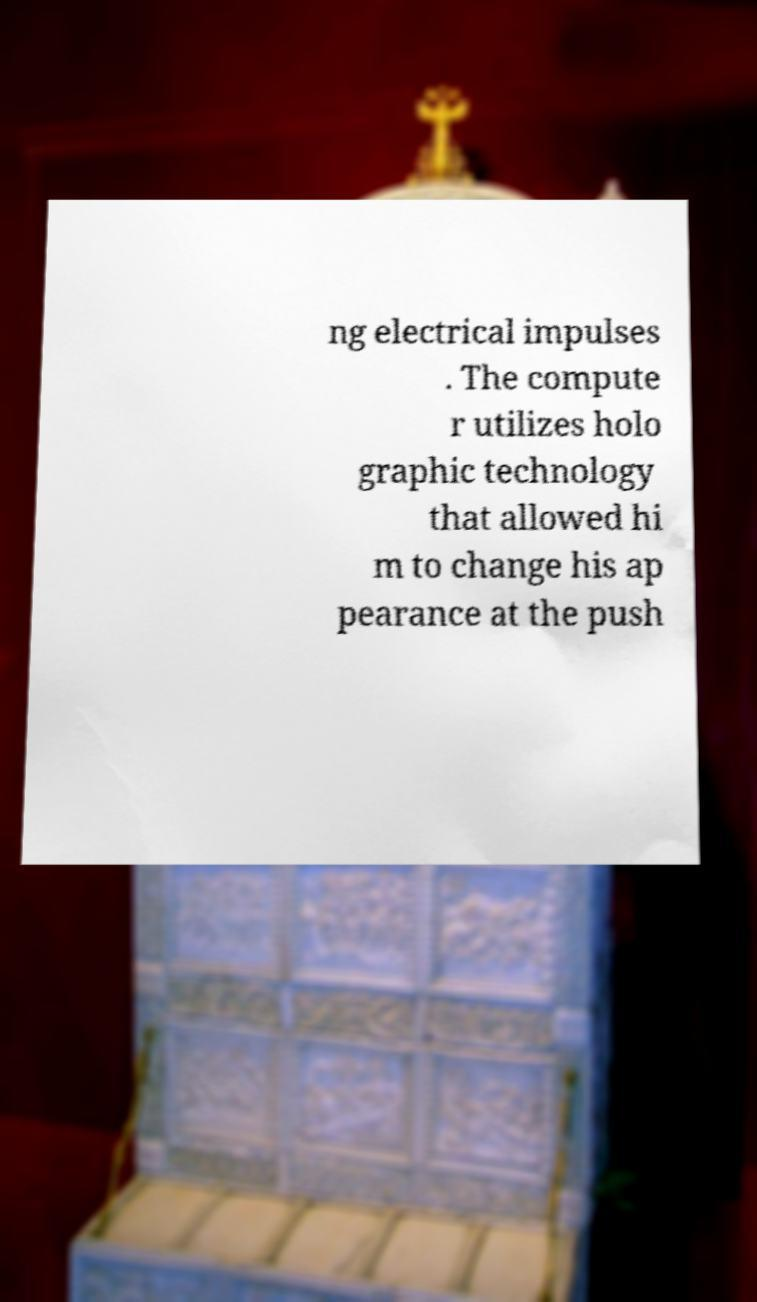Please read and relay the text visible in this image. What does it say? ng electrical impulses . The compute r utilizes holo graphic technology that allowed hi m to change his ap pearance at the push 